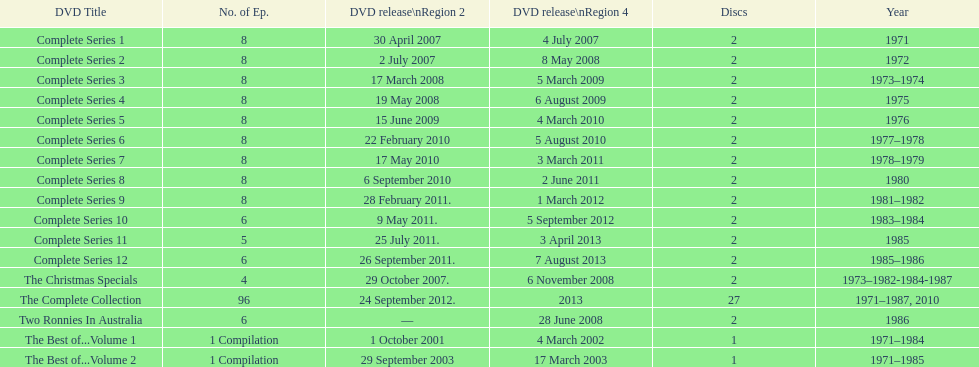The complete collection has 96 episodes, but the christmas specials only has how many episodes? 4. 